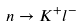Convert formula to latex. <formula><loc_0><loc_0><loc_500><loc_500>n \to K ^ { + } l ^ { - }</formula> 